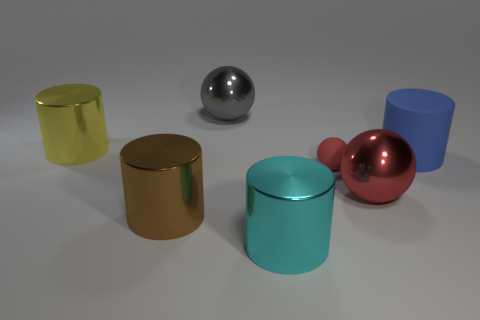Add 2 large gray rubber blocks. How many objects exist? 9 Subtract all spheres. How many objects are left? 4 Add 3 yellow cylinders. How many yellow cylinders exist? 4 Subtract 0 yellow blocks. How many objects are left? 7 Subtract all small green matte things. Subtract all brown metallic cylinders. How many objects are left? 6 Add 2 brown things. How many brown things are left? 3 